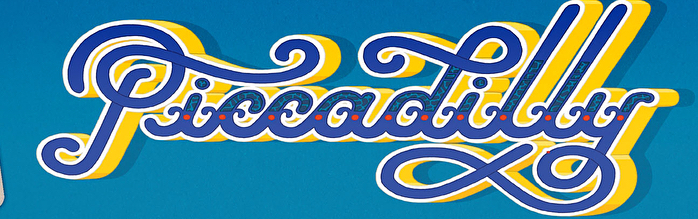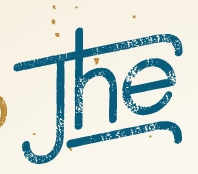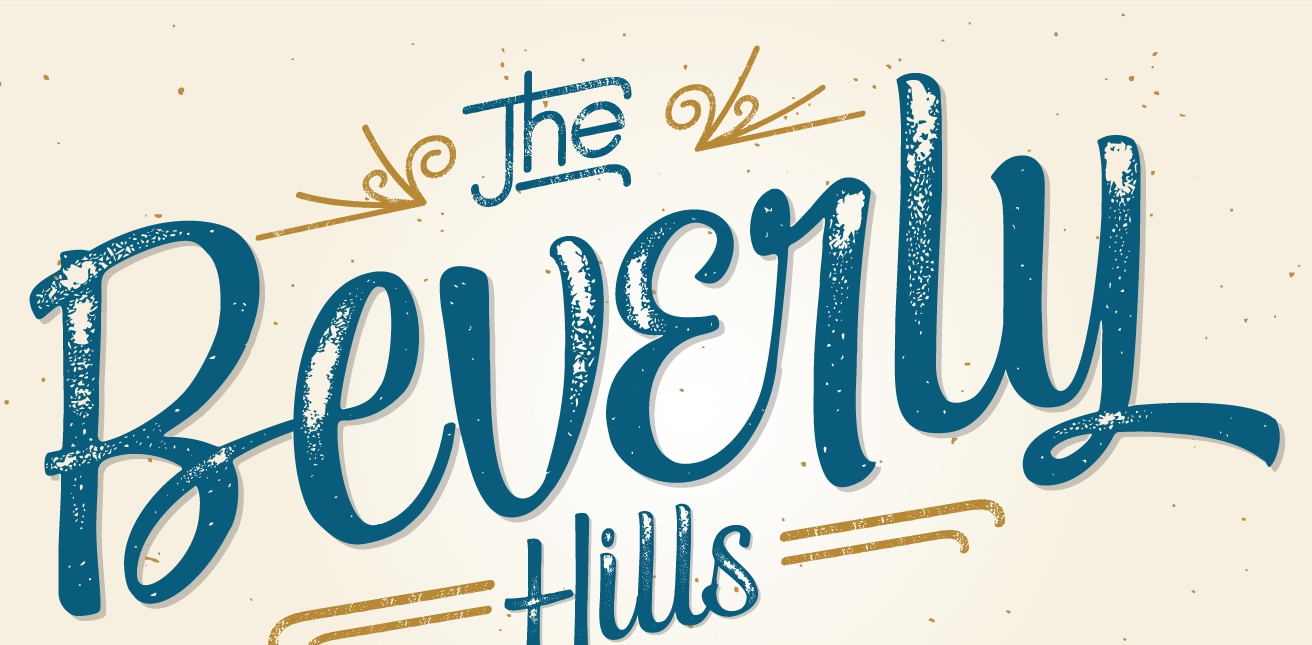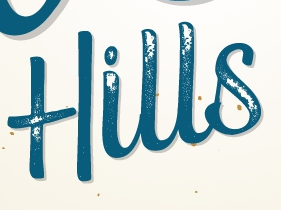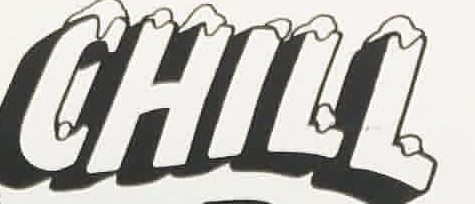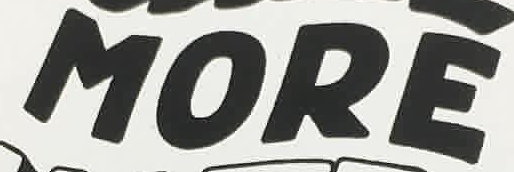What text is displayed in these images sequentially, separated by a semicolon? Piccadilly; The; Beverly; Hills; CHILL; MORE 